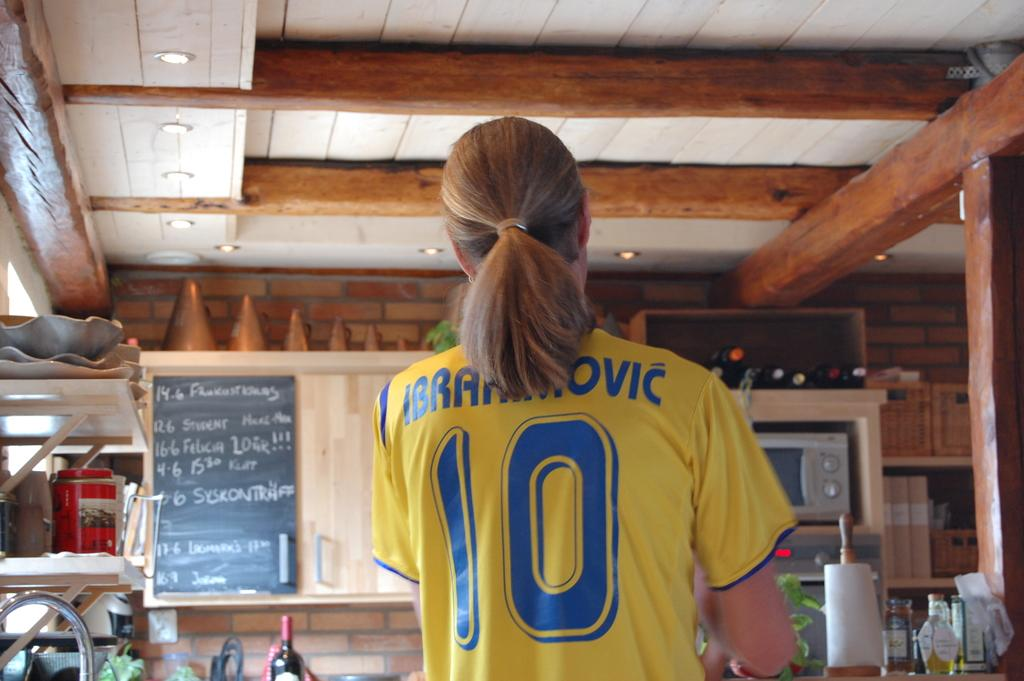Provide a one-sentence caption for the provided image. a person with a ponytail wearing a shirt that says the number 10 on it. 